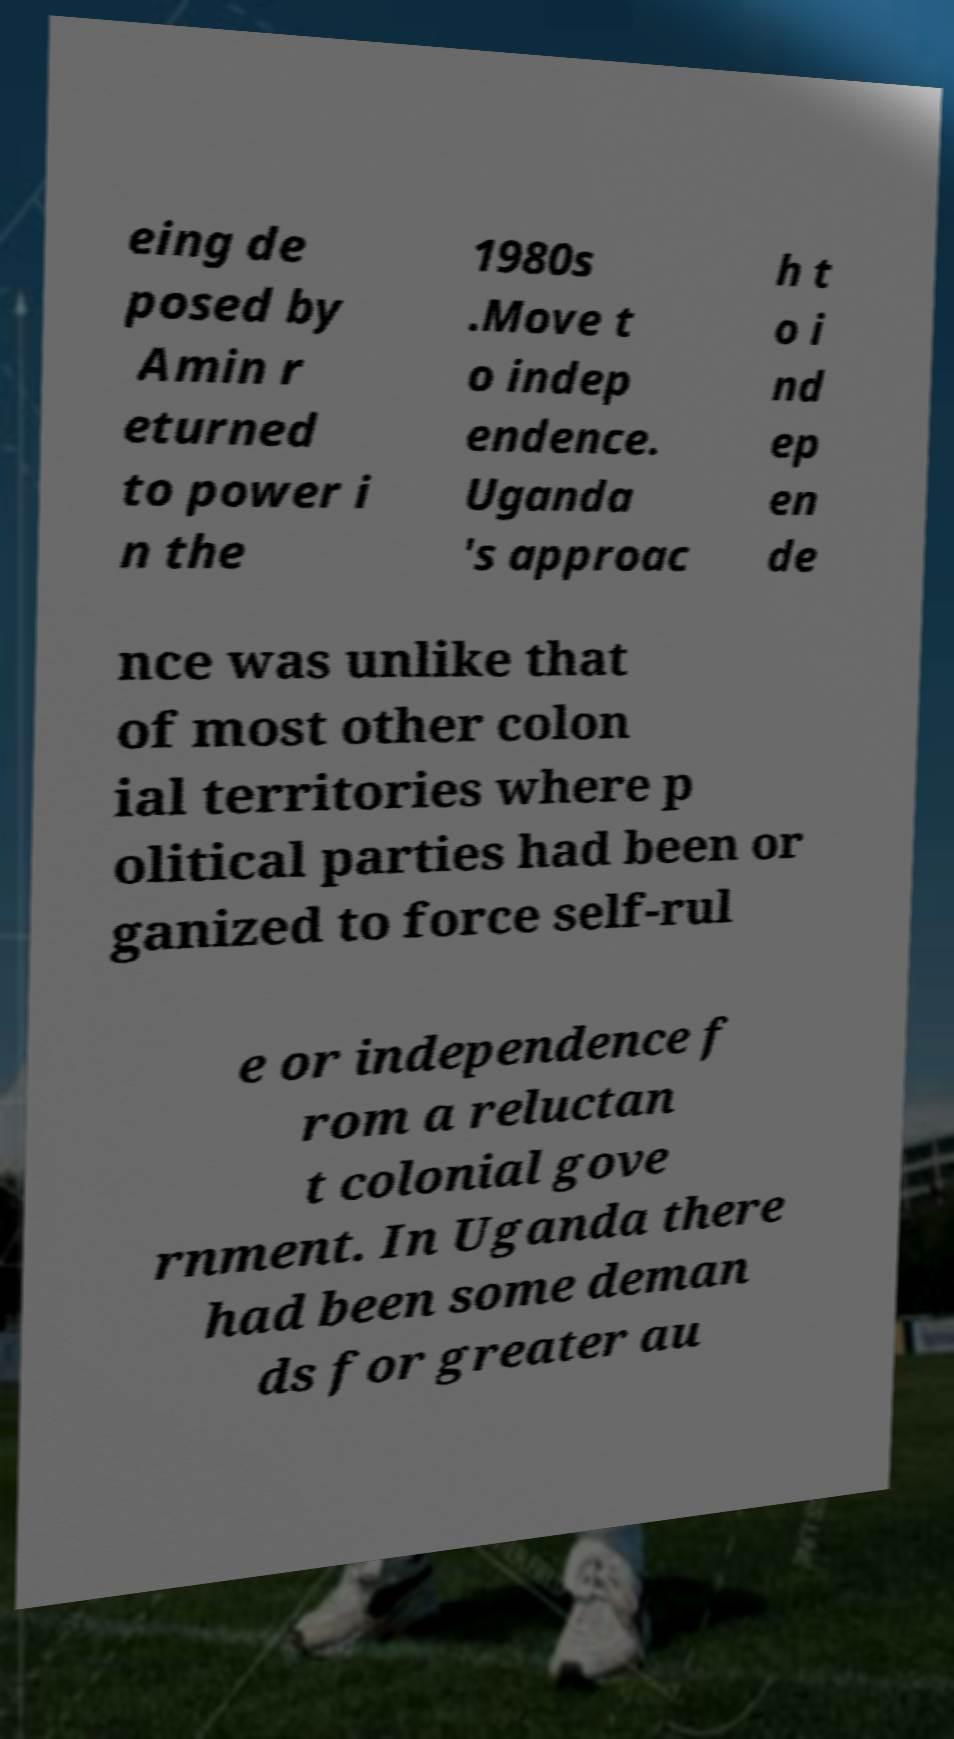Please read and relay the text visible in this image. What does it say? eing de posed by Amin r eturned to power i n the 1980s .Move t o indep endence. Uganda 's approac h t o i nd ep en de nce was unlike that of most other colon ial territories where p olitical parties had been or ganized to force self-rul e or independence f rom a reluctan t colonial gove rnment. In Uganda there had been some deman ds for greater au 